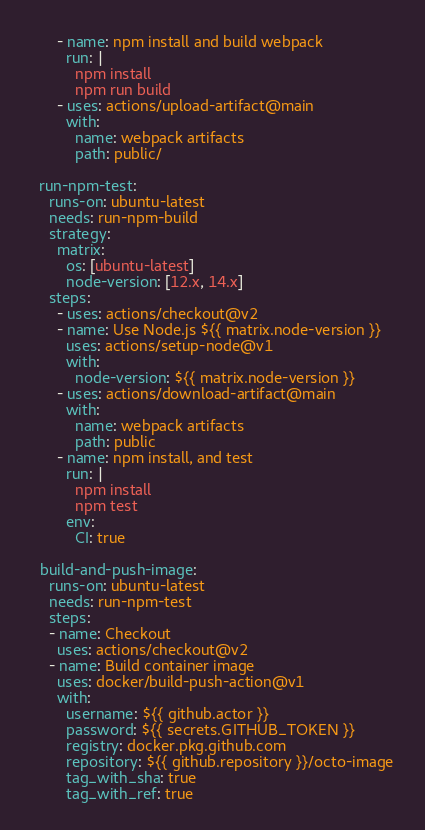<code> <loc_0><loc_0><loc_500><loc_500><_YAML_>      - name: npm install and build webpack
        run: |
          npm install
          npm run build
      - uses: actions/upload-artifact@main
        with:
          name: webpack artifacts
          path: public/

  run-npm-test:
    runs-on: ubuntu-latest
    needs: run-npm-build
    strategy:
      matrix:
        os: [ubuntu-latest]
        node-version: [12.x, 14.x]
    steps:
      - uses: actions/checkout@v2
      - name: Use Node.js ${{ matrix.node-version }}
        uses: actions/setup-node@v1
        with:
          node-version: ${{ matrix.node-version }}
      - uses: actions/download-artifact@main
        with:
          name: webpack artifacts
          path: public
      - name: npm install, and test
        run: |
          npm install
          npm test
        env:
          CI: true

  build-and-push-image:
    runs-on: ubuntu-latest
    needs: run-npm-test
    steps:
    - name: Checkout
      uses: actions/checkout@v2
    - name: Build container image
      uses: docker/build-push-action@v1
      with:
        username: ${{ github.actor }}
        password: ${{ secrets.GITHUB_TOKEN }}
        registry: docker.pkg.github.com
        repository: ${{ github.repository }}/octo-image
        tag_with_sha: true
        tag_with_ref: true 
</code> 